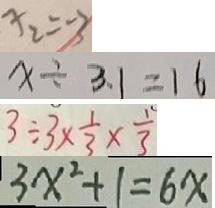Convert formula to latex. <formula><loc_0><loc_0><loc_500><loc_500>x _ { 2 } = - 3 
 x \div 3 . 1 = 1 6 
 3 \div 3 \times \frac { 1 } { 3 } \times \frac { 1 } { 3 } 
 3 x ^ { 2 } + 1 = 6 x</formula> 